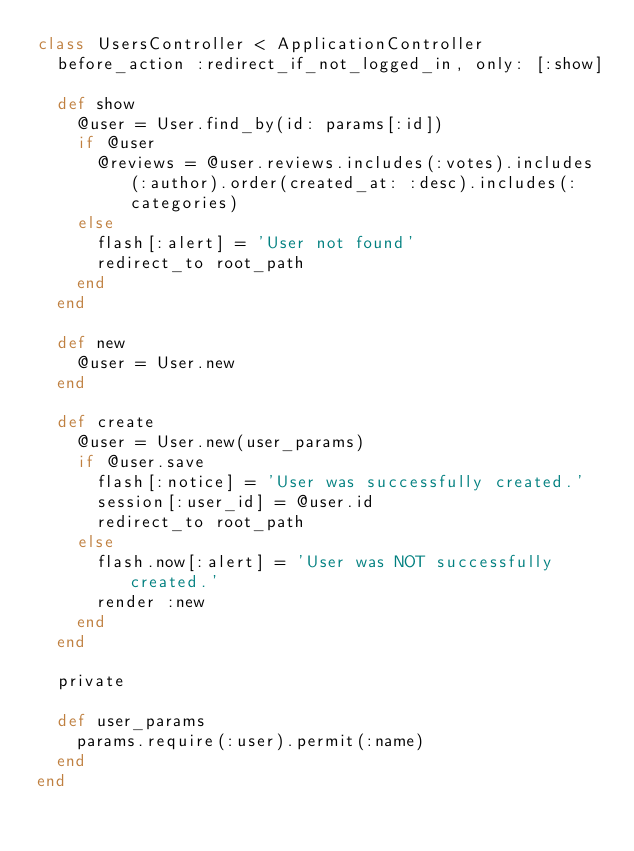<code> <loc_0><loc_0><loc_500><loc_500><_Ruby_>class UsersController < ApplicationController
  before_action :redirect_if_not_logged_in, only: [:show]

  def show
    @user = User.find_by(id: params[:id])
    if @user
      @reviews = @user.reviews.includes(:votes).includes(:author).order(created_at: :desc).includes(:categories)
    else
      flash[:alert] = 'User not found'
      redirect_to root_path
    end
  end

  def new
    @user = User.new
  end

  def create
    @user = User.new(user_params)
    if @user.save
      flash[:notice] = 'User was successfully created.'
      session[:user_id] = @user.id
      redirect_to root_path
    else
      flash.now[:alert] = 'User was NOT successfully created.'
      render :new
    end
  end

  private

  def user_params
    params.require(:user).permit(:name)
  end
end
</code> 